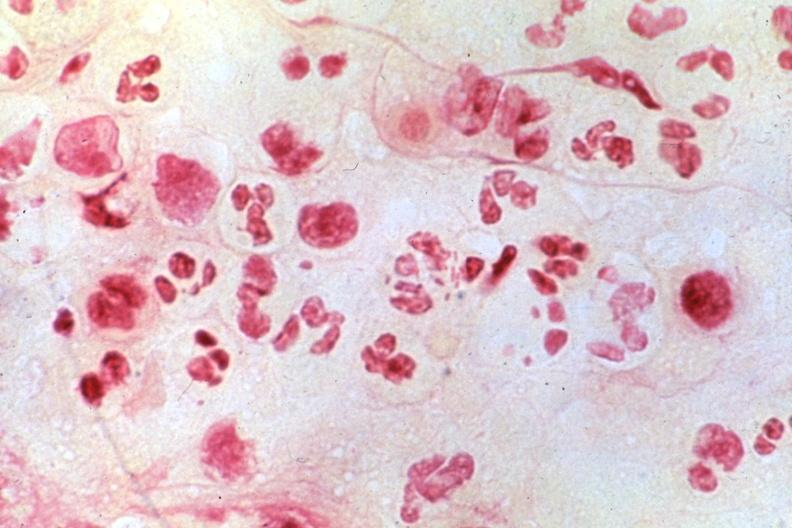what does this image show?
Answer the question using a single word or phrase. Chancroid 